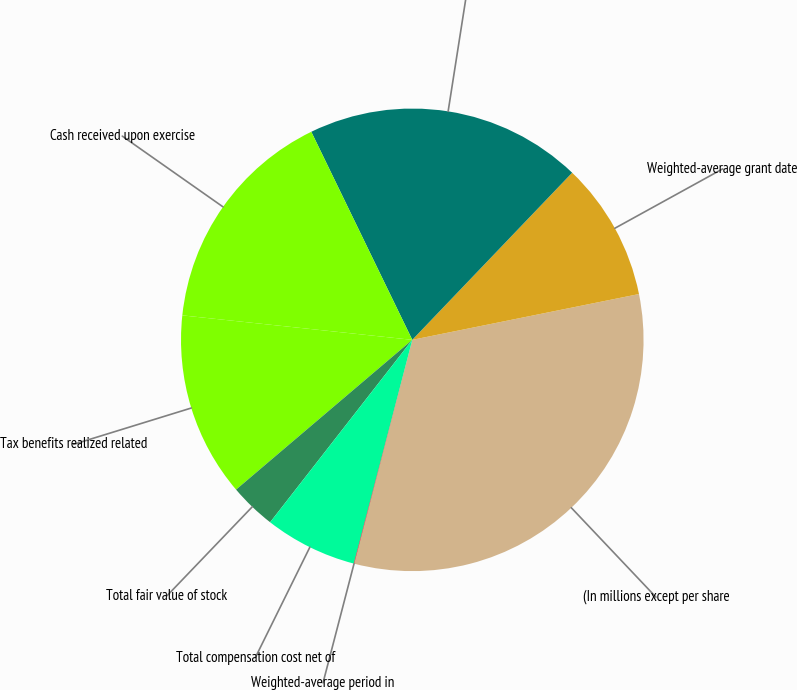Convert chart. <chart><loc_0><loc_0><loc_500><loc_500><pie_chart><fcel>(In millions except per share<fcel>Weighted-average grant date<fcel>Aggregate intrinsic value on<fcel>Cash received upon exercise<fcel>Tax benefits realized related<fcel>Total fair value of stock<fcel>Total compensation cost net of<fcel>Weighted-average period in<nl><fcel>32.21%<fcel>9.68%<fcel>19.34%<fcel>16.12%<fcel>12.9%<fcel>3.25%<fcel>6.47%<fcel>0.03%<nl></chart> 